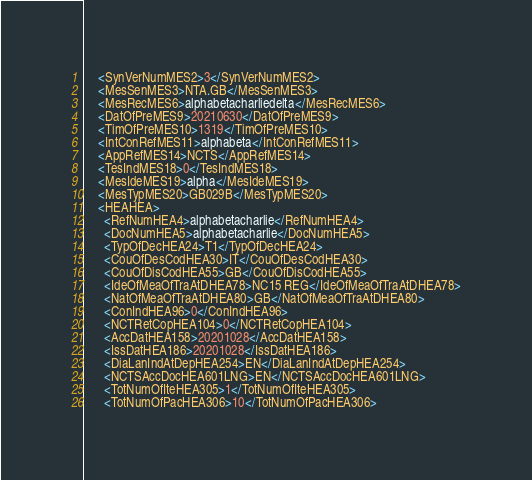Convert code to text. <code><loc_0><loc_0><loc_500><loc_500><_Scala_>    <SynVerNumMES2>3</SynVerNumMES2>
    <MesSenMES3>NTA.GB</MesSenMES3>
    <MesRecMES6>alphabetacharliedelta</MesRecMES6>
    <DatOfPreMES9>20210630</DatOfPreMES9>
    <TimOfPreMES10>1319</TimOfPreMES10>
    <IntConRefMES11>alphabeta</IntConRefMES11>
    <AppRefMES14>NCTS</AppRefMES14>
    <TesIndMES18>0</TesIndMES18>
    <MesIdeMES19>alpha</MesIdeMES19>
    <MesTypMES20>GB029B</MesTypMES20>
    <HEAHEA>
      <RefNumHEA4>alphabetacharlie</RefNumHEA4>
      <DocNumHEA5>alphabetacharlie</DocNumHEA5>
      <TypOfDecHEA24>T1</TypOfDecHEA24>
      <CouOfDesCodHEA30>IT</CouOfDesCodHEA30>
      <CouOfDisCodHEA55>GB</CouOfDisCodHEA55>
      <IdeOfMeaOfTraAtDHEA78>NC15 REG</IdeOfMeaOfTraAtDHEA78>
      <NatOfMeaOfTraAtDHEA80>GB</NatOfMeaOfTraAtDHEA80>
      <ConIndHEA96>0</ConIndHEA96>
      <NCTRetCopHEA104>0</NCTRetCopHEA104>
      <AccDatHEA158>20201028</AccDatHEA158>
      <IssDatHEA186>20201028</IssDatHEA186>
      <DiaLanIndAtDepHEA254>EN</DiaLanIndAtDepHEA254>
      <NCTSAccDocHEA601LNG>EN</NCTSAccDocHEA601LNG>
      <TotNumOfIteHEA305>1</TotNumOfIteHEA305>
      <TotNumOfPacHEA306>10</TotNumOfPacHEA306></code> 